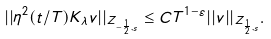<formula> <loc_0><loc_0><loc_500><loc_500>| | \eta ^ { 2 } ( t / T ) K _ { \lambda } v | | _ { Z _ { - \frac { 1 } { 2 } , s } } \leq C T ^ { 1 - \varepsilon } | | v | | _ { Z _ { \frac { 1 } { 2 } , s } } .</formula> 